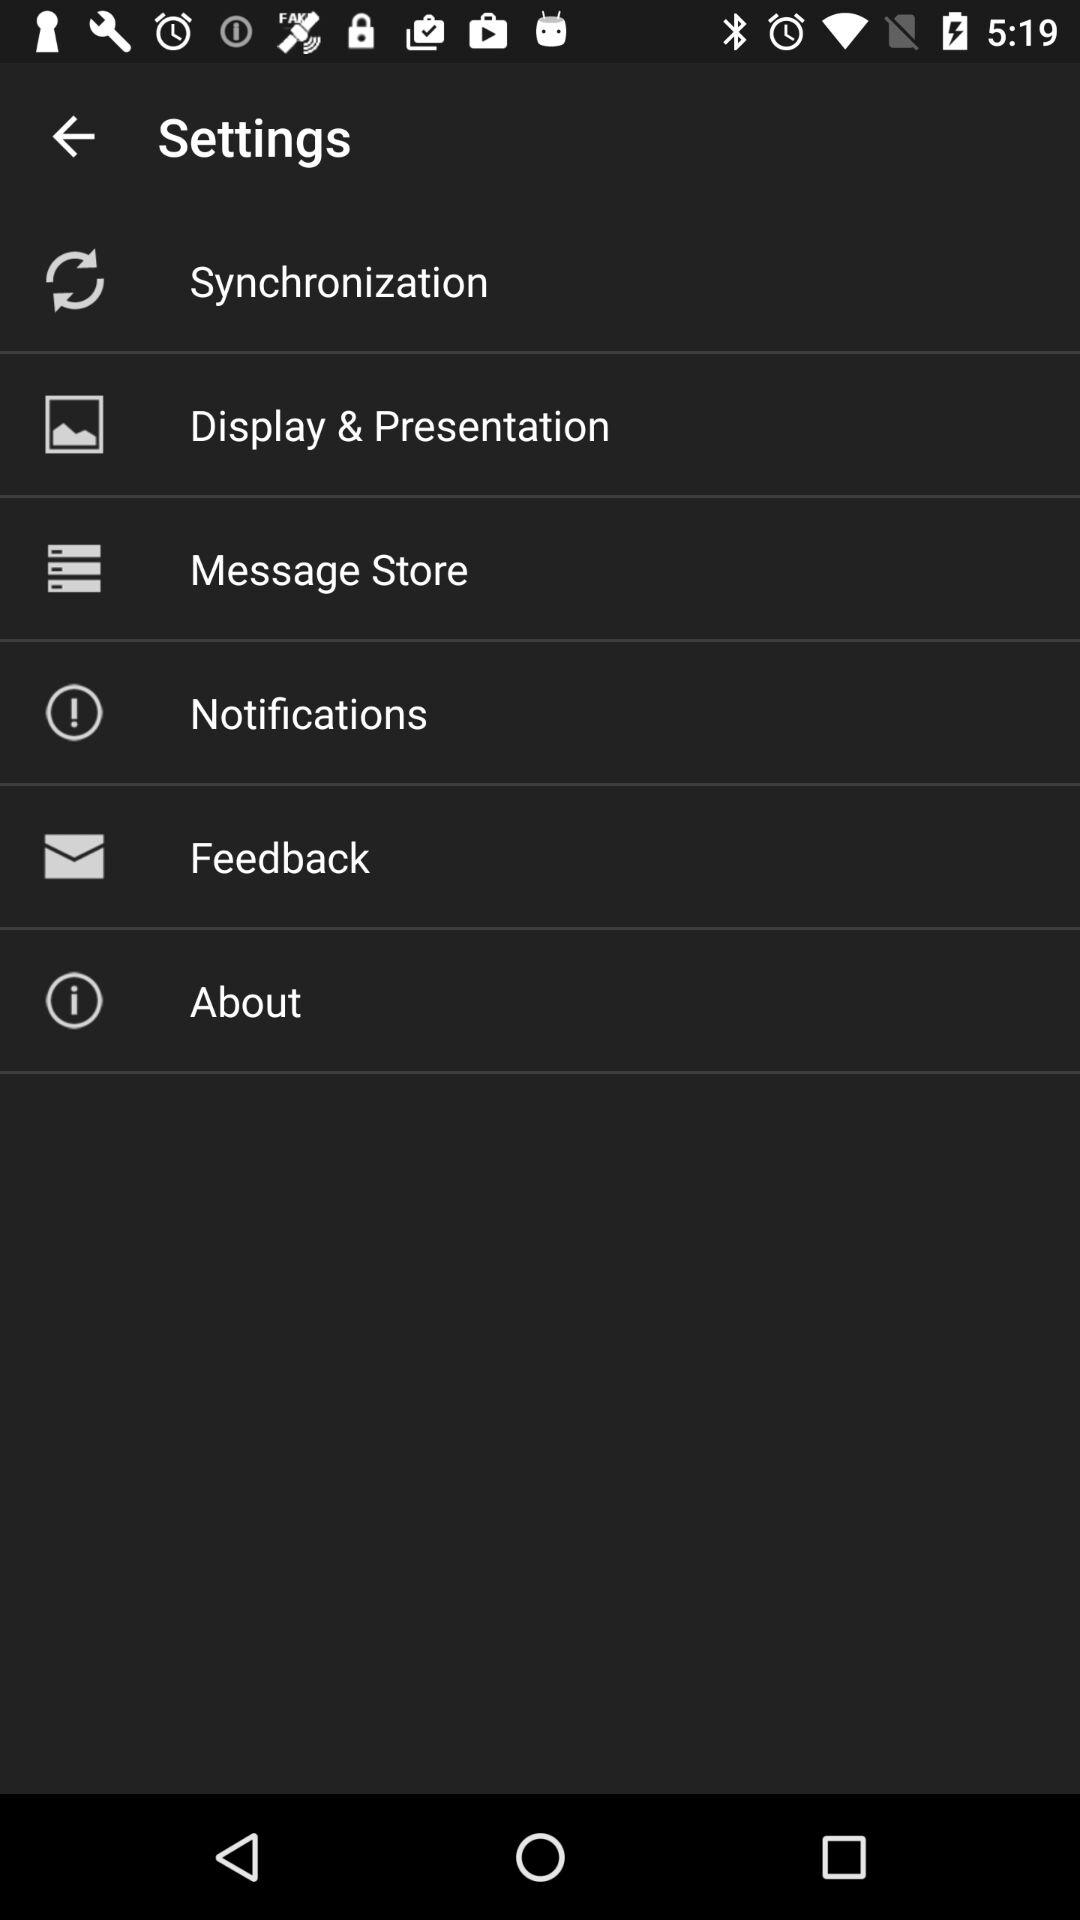How many items are in the settings menu?
Answer the question using a single word or phrase. 6 